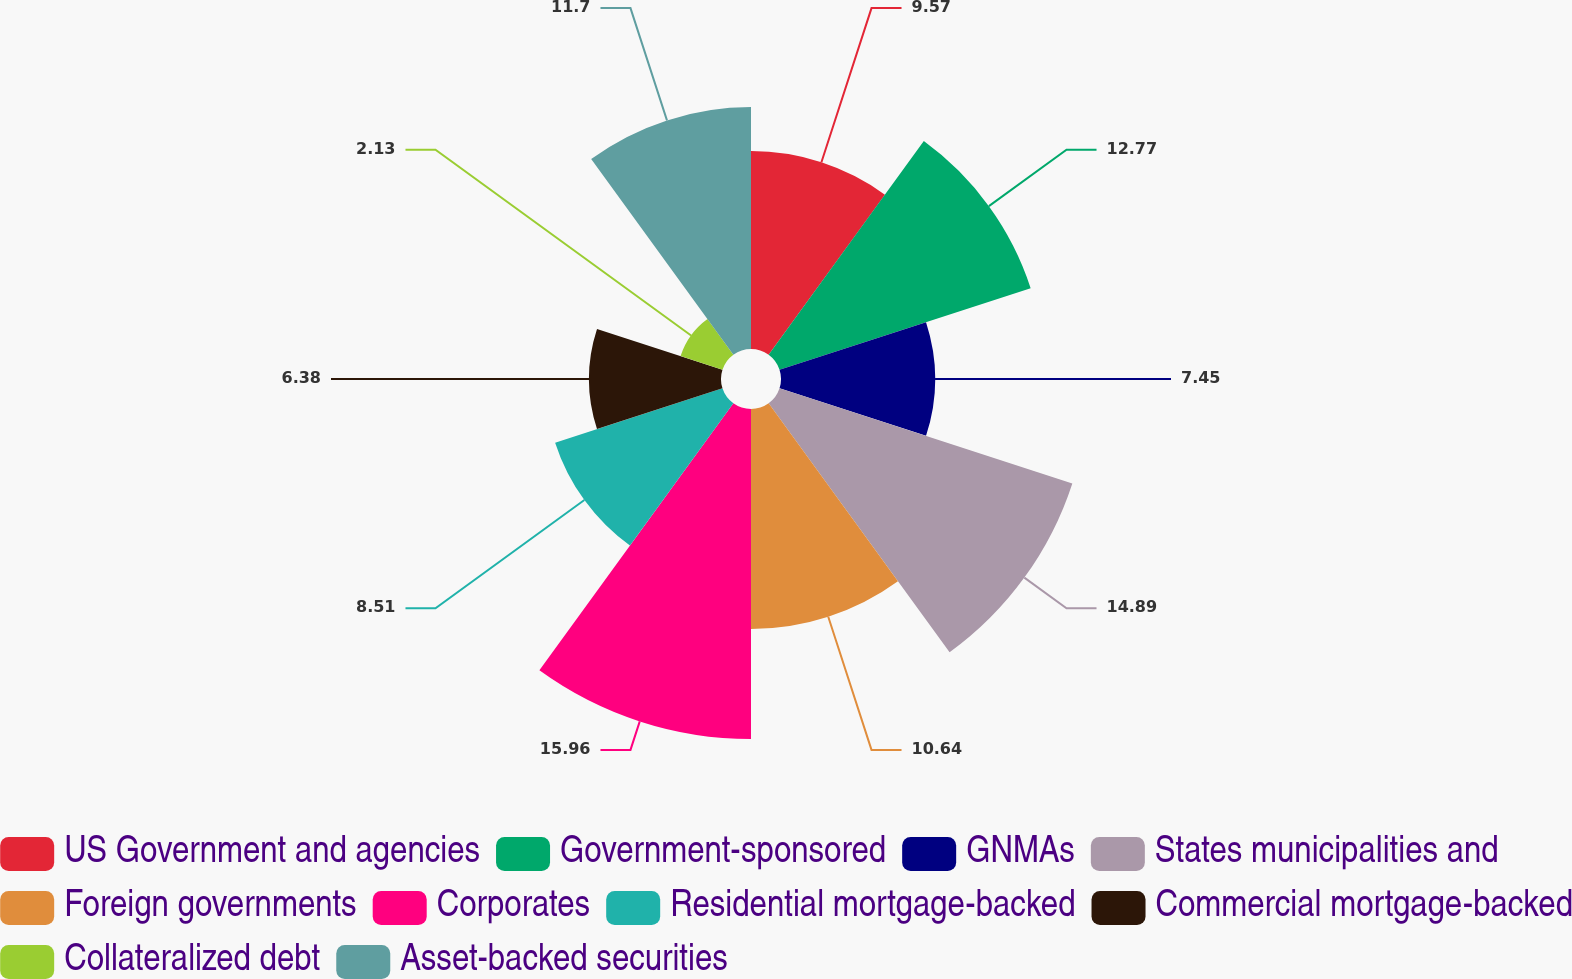Convert chart. <chart><loc_0><loc_0><loc_500><loc_500><pie_chart><fcel>US Government and agencies<fcel>Government-sponsored<fcel>GNMAs<fcel>States municipalities and<fcel>Foreign governments<fcel>Corporates<fcel>Residential mortgage-backed<fcel>Commercial mortgage-backed<fcel>Collateralized debt<fcel>Asset-backed securities<nl><fcel>9.57%<fcel>12.77%<fcel>7.45%<fcel>14.89%<fcel>10.64%<fcel>15.96%<fcel>8.51%<fcel>6.38%<fcel>2.13%<fcel>11.7%<nl></chart> 